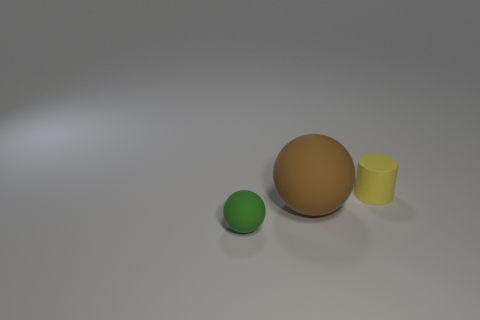Is there another object of the same shape as the small green thing?
Keep it short and to the point. Yes. What number of objects are either rubber objects in front of the cylinder or large red cylinders?
Provide a short and direct response. 2. Are there more small green rubber objects behind the green matte sphere than small green spheres behind the yellow cylinder?
Provide a succinct answer. No. What number of matte objects are cylinders or cyan cubes?
Provide a succinct answer. 1. Are there fewer rubber cylinders that are left of the tiny cylinder than balls that are behind the brown rubber object?
Offer a terse response. No. How many objects are either green rubber spheres or rubber things in front of the brown rubber sphere?
Provide a succinct answer. 1. What material is the ball that is the same size as the yellow rubber object?
Your response must be concise. Rubber. Are the yellow thing and the brown sphere made of the same material?
Offer a terse response. Yes. There is a rubber object that is in front of the tiny yellow matte object and to the right of the small rubber sphere; what is its color?
Keep it short and to the point. Brown. There is a small thing in front of the matte cylinder; is its color the same as the small rubber cylinder?
Your answer should be compact. No. 